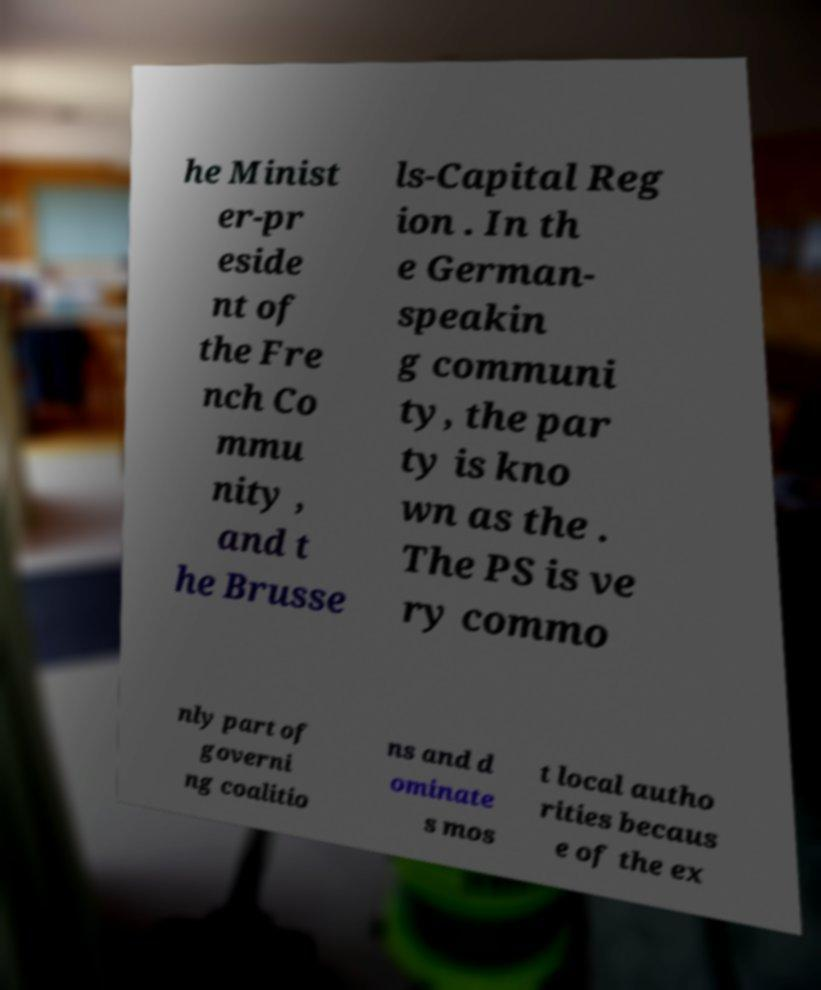Could you assist in decoding the text presented in this image and type it out clearly? he Minist er-pr eside nt of the Fre nch Co mmu nity , and t he Brusse ls-Capital Reg ion . In th e German- speakin g communi ty, the par ty is kno wn as the . The PS is ve ry commo nly part of governi ng coalitio ns and d ominate s mos t local autho rities becaus e of the ex 